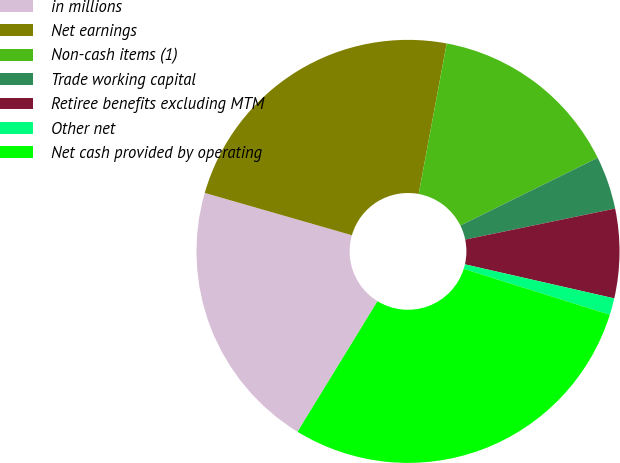Convert chart to OTSL. <chart><loc_0><loc_0><loc_500><loc_500><pie_chart><fcel>in millions<fcel>Net earnings<fcel>Non-cash items (1)<fcel>Trade working capital<fcel>Retiree benefits excluding MTM<fcel>Other net<fcel>Net cash provided by operating<nl><fcel>20.71%<fcel>23.47%<fcel>14.78%<fcel>4.05%<fcel>6.81%<fcel>1.28%<fcel>28.9%<nl></chart> 